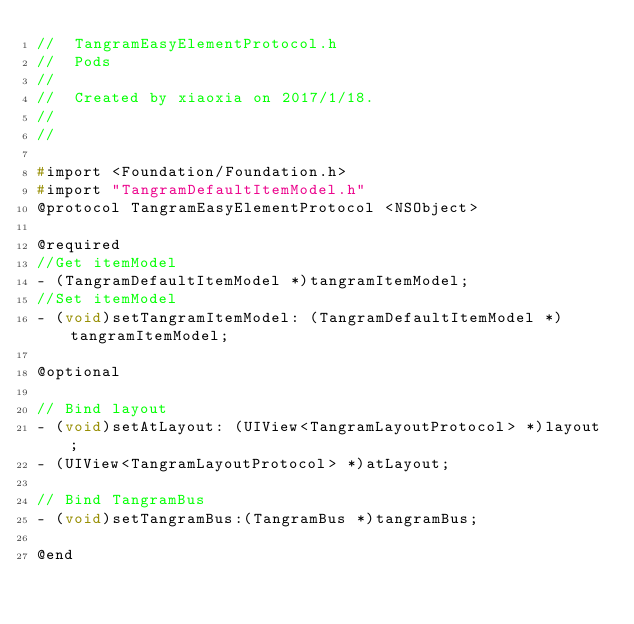Convert code to text. <code><loc_0><loc_0><loc_500><loc_500><_C_>//  TangramEasyElementProtocol.h
//  Pods
//
//  Created by xiaoxia on 2017/1/18.
//
//

#import <Foundation/Foundation.h>
#import "TangramDefaultItemModel.h"
@protocol TangramEasyElementProtocol <NSObject>

@required
//Get itemModel
- (TangramDefaultItemModel *)tangramItemModel;
//Set itemModel
- (void)setTangramItemModel: (TangramDefaultItemModel *)tangramItemModel;

@optional

// Bind layout
- (void)setAtLayout: (UIView<TangramLayoutProtocol> *)layout;
- (UIView<TangramLayoutProtocol> *)atLayout;

// Bind TangramBus
- (void)setTangramBus:(TangramBus *)tangramBus;

@end
</code> 